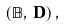Convert formula to latex. <formula><loc_0><loc_0><loc_500><loc_500>( { \mathbb { B } } , \, { \mathbf D } ) \, ,</formula> 